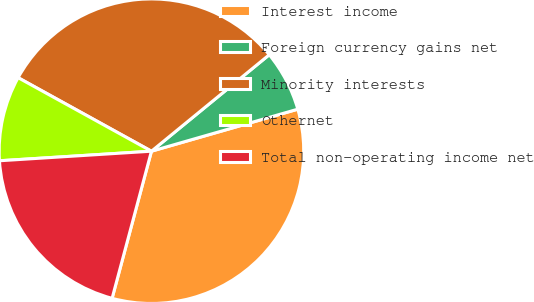Convert chart to OTSL. <chart><loc_0><loc_0><loc_500><loc_500><pie_chart><fcel>Interest income<fcel>Foreign currency gains net<fcel>Minority interests<fcel>Othernet<fcel>Total non-operating income net<nl><fcel>33.61%<fcel>6.47%<fcel>31.06%<fcel>9.02%<fcel>19.84%<nl></chart> 